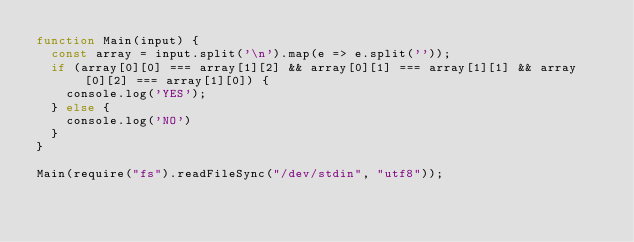<code> <loc_0><loc_0><loc_500><loc_500><_JavaScript_>function Main(input) {
  const array = input.split('\n').map(e => e.split(''));
  if (array[0][0] === array[1][2] && array[0][1] === array[1][1] && array[0][2] === array[1][0]) {
    console.log('YES');
  } else {
    console.log('NO')
  }
}

Main(require("fs").readFileSync("/dev/stdin", "utf8"));</code> 